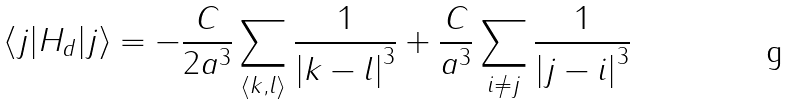Convert formula to latex. <formula><loc_0><loc_0><loc_500><loc_500>\langle j | H _ { d } | j \rangle = - \frac { C } { 2 a ^ { 3 } } \sum _ { \langle k , l \rangle } \frac { 1 } { { | k - l | } ^ { 3 } } + \frac { C } { a ^ { 3 } } \sum _ { i \not = j } \frac { 1 } { { | j - i | } ^ { 3 } }</formula> 